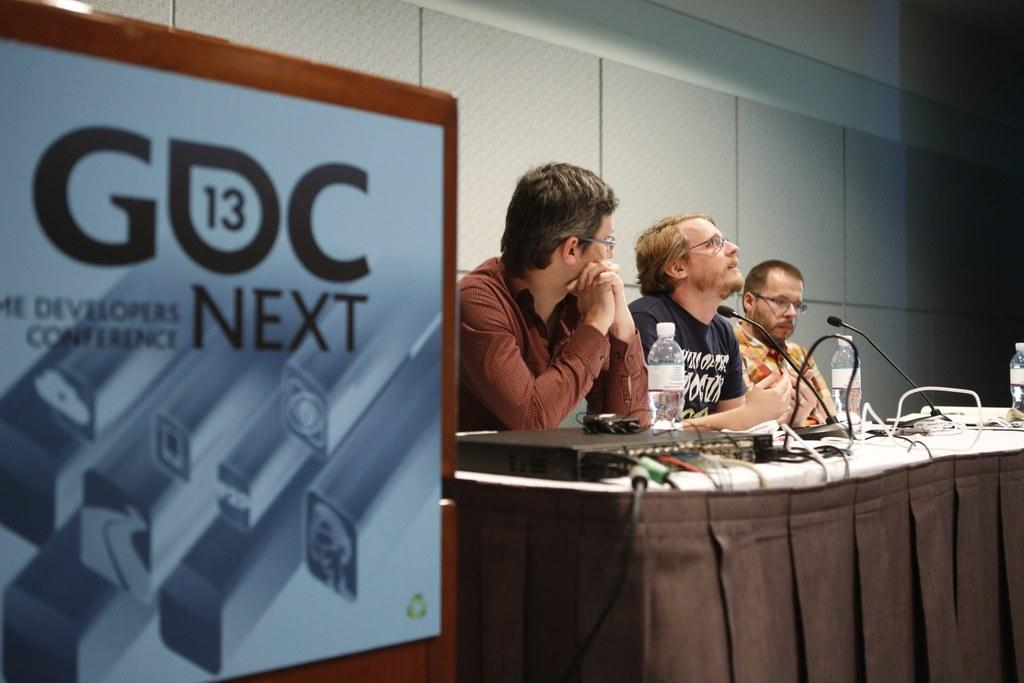What type of flooring is visible in the image? There are tiles in the image. What can be seen hanging or displayed in the image? There is a banner in the image. What are the people in the image doing? The people are sitting on chairs in the image. What furniture is present in the image? There is a table in the image. What equipment is on the table in the image? There is a projector, bottles, papers, and microphones on the table in the image. Can you tell me how many eggs are in the lake in the image? There is no lake or eggs present in the image. What type of development is shown in the image? There is no development or reference to development in the image. 